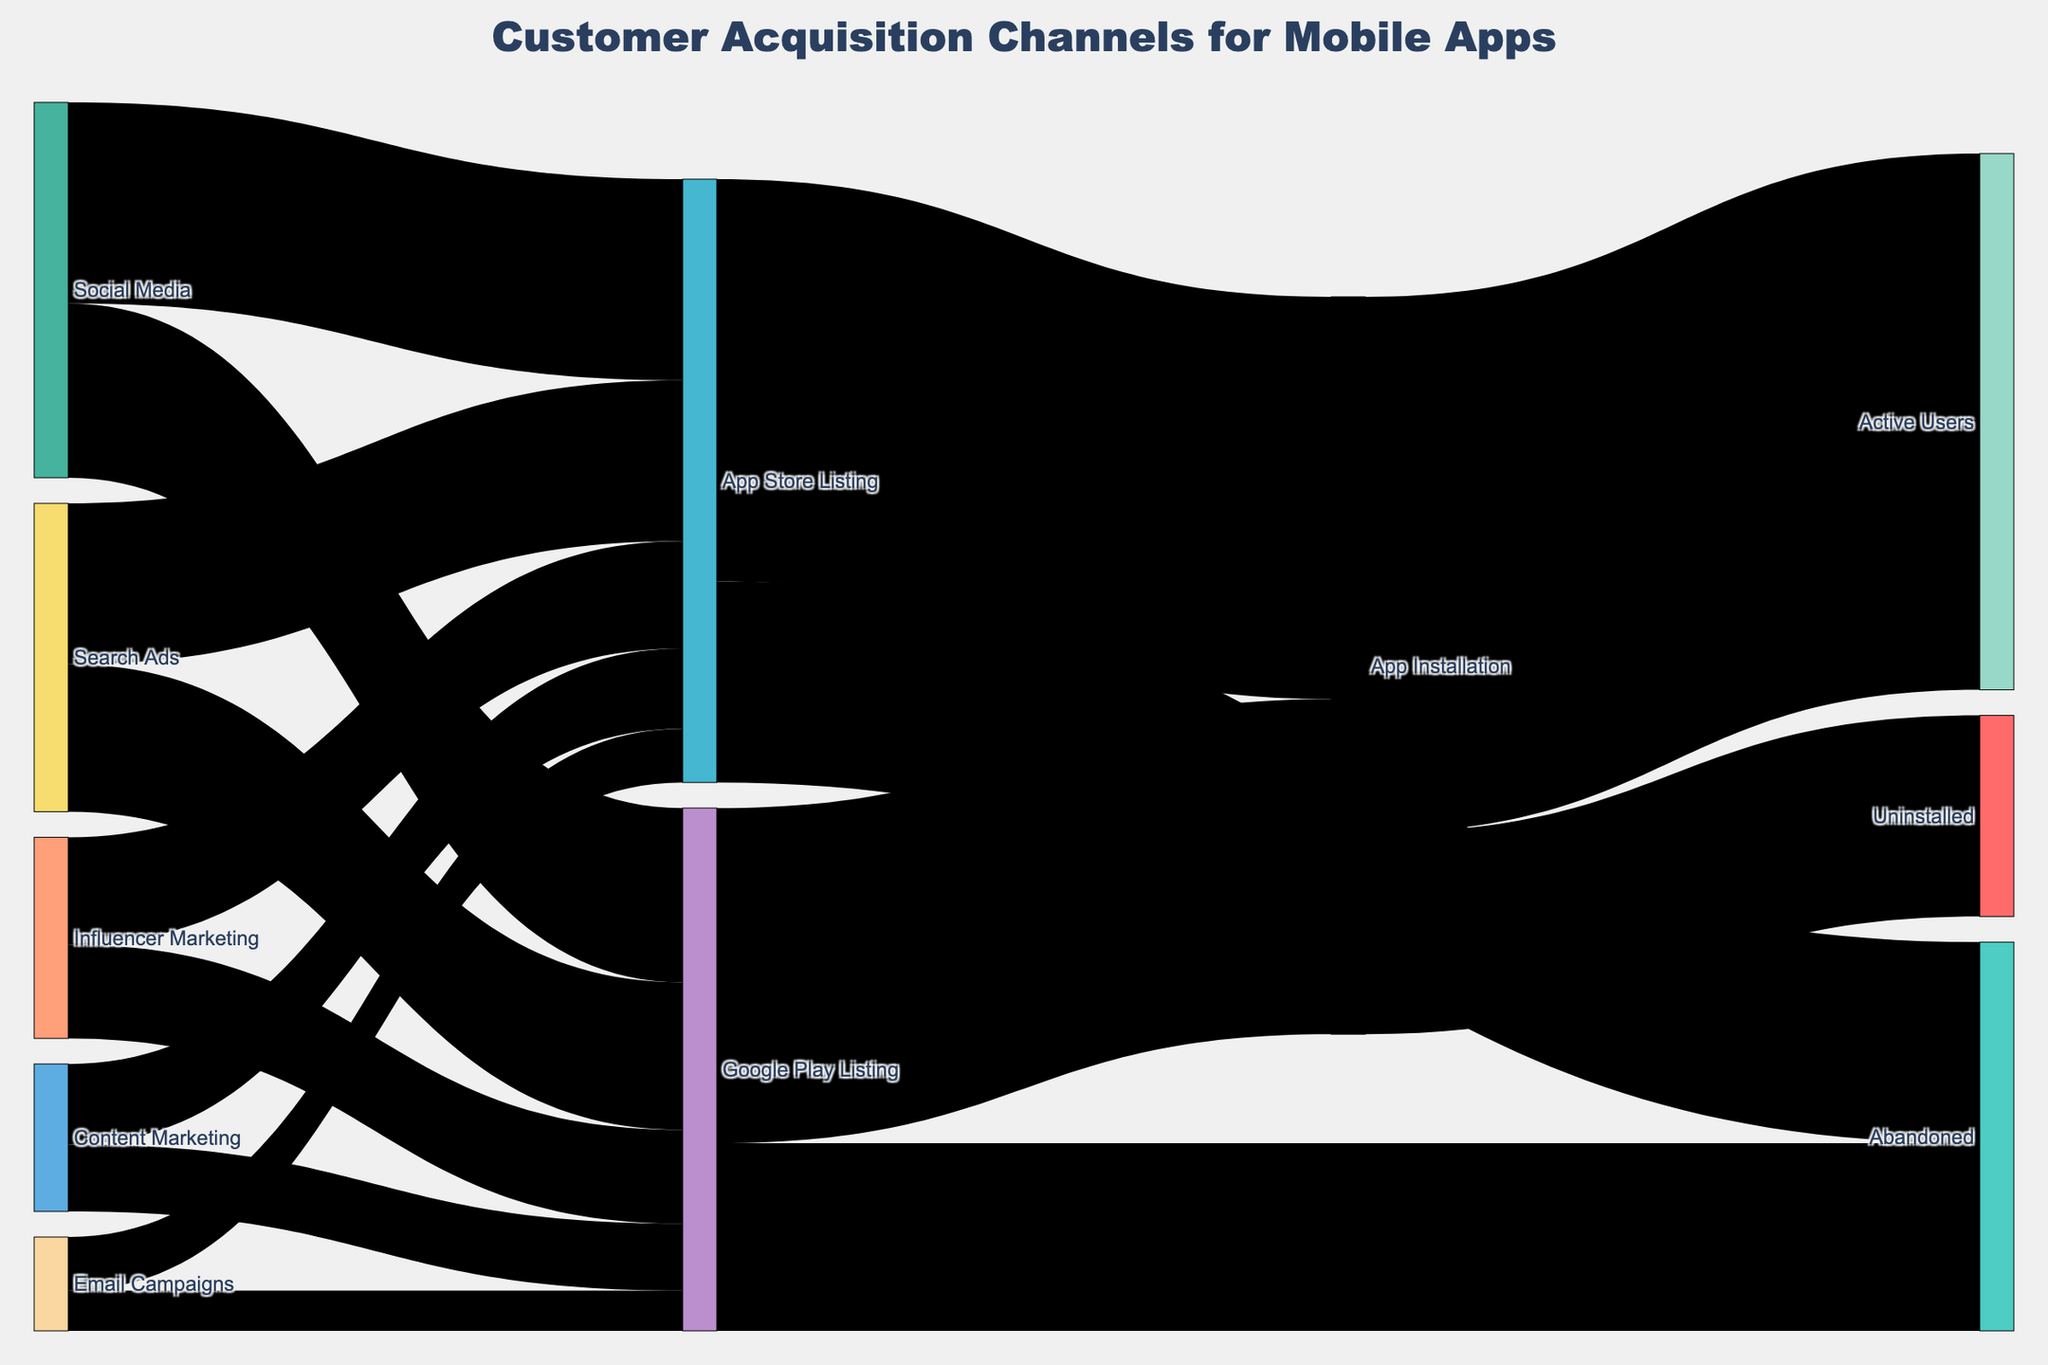What is the title of the figure? The title of the figure is found at the top and clearly states what the diagram is about.
Answer: Customer Acquisition Channels for Mobile Apps How many users came from Social Media and ended up installing the app? To find this, locate the path from Social Media to App Installation through the intermediate listings (App Store Listing and Google Play Listing). Add the values from both paths: 1500 (Social Media to App Store Listing) * (3000/4500) + 1300 (Social Media to Google Play Listing) * (2500/3900). Performing the calculations, we get approximately 1000 + 833.
Answer: 1833 Which source channel contributed the least number of installations? Examine the values of all paths leading to App Installation and see which channel has the smallest contribution. Email Campaigns to both App Store Listing and Google Play Listing show the lowest values and numbers, leading to the least installation counts.
Answer: Email Campaigns What is the total number of users that reached the App Installation from all sources? Add up the values flowing into App Installation from both the App Store Listing and the Google Play Listing paths: 3000 from App Store Listing + 2500 from Google Play Listing. The sum is 3000 + 2500.
Answer: 5500 What percentage of users who installed the app became active users? Calculate the percentage by dividing the value of Active Users by the total App Installation value, then multiplying by 100: (4000 / 5500) * 100. Perform the math: (4000 / 5500) * 100 ≈ 72.73.
Answer: 72.73% Which channel resulted in the most abandoned listings? Compare the abandonment values from App Store Listing and Google Play Listing. App Store Listing has an abandonment value of 1500, and Google Play Listing has 1400, indicating the higher number.
Answer: App Store Listing How many abandoned listings came from Search Ads? Check the individual contributions from Search Ads and trace to App Store and Google Play Listings, then to the Abandoned listings. Calculate: (1200 * 1500/4500) + (1100 * 1400/3900).
Answer: Approximately 700 What is the difference in the number of installations obtained from App Store Listing compared to Google Play Listing? Subtract the number of App Installations from Google Play Listing from those from App Store Listing: 3000 - 2500.
Answer: 500 What percentage of users from Influencer Marketing ended up in the App Store Listing? Use the total value from Influencer Marketing and calculate the percentage flowing into App Store Listing: (800 / 2300) * 100. Perform the math: (800 / 2300) * 100 ≈ 34.78.
Answer: 34.78% How many more users did Content Marketing bring to app installations than Email Campaigns? Trace the path from each source to app installations and then compare: ((600 * 3000/4500) + (500 * 2500/3900)) - ((400 * 3000/4500) + (300 * 2500/3900)).
Answer: Approximately 528 users 